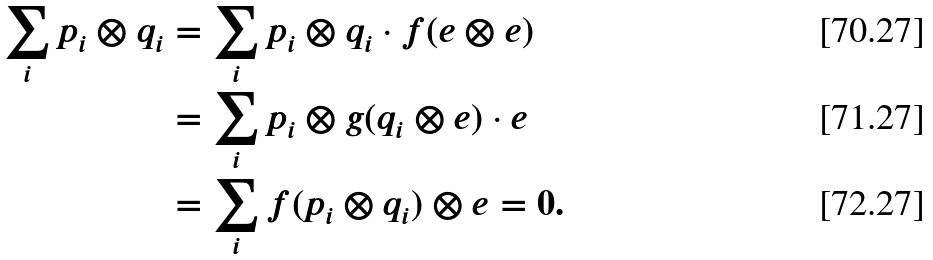<formula> <loc_0><loc_0><loc_500><loc_500>\sum _ { i } p _ { i } \otimes q _ { i } & = \sum _ { i } p _ { i } \otimes q _ { i } \cdot f ( e \otimes e ) \\ & = \sum _ { i } p _ { i } \otimes g ( q _ { i } \otimes e ) \cdot e \\ & = \sum _ { i } f ( p _ { i } \otimes q _ { i } ) \otimes e = 0 .</formula> 